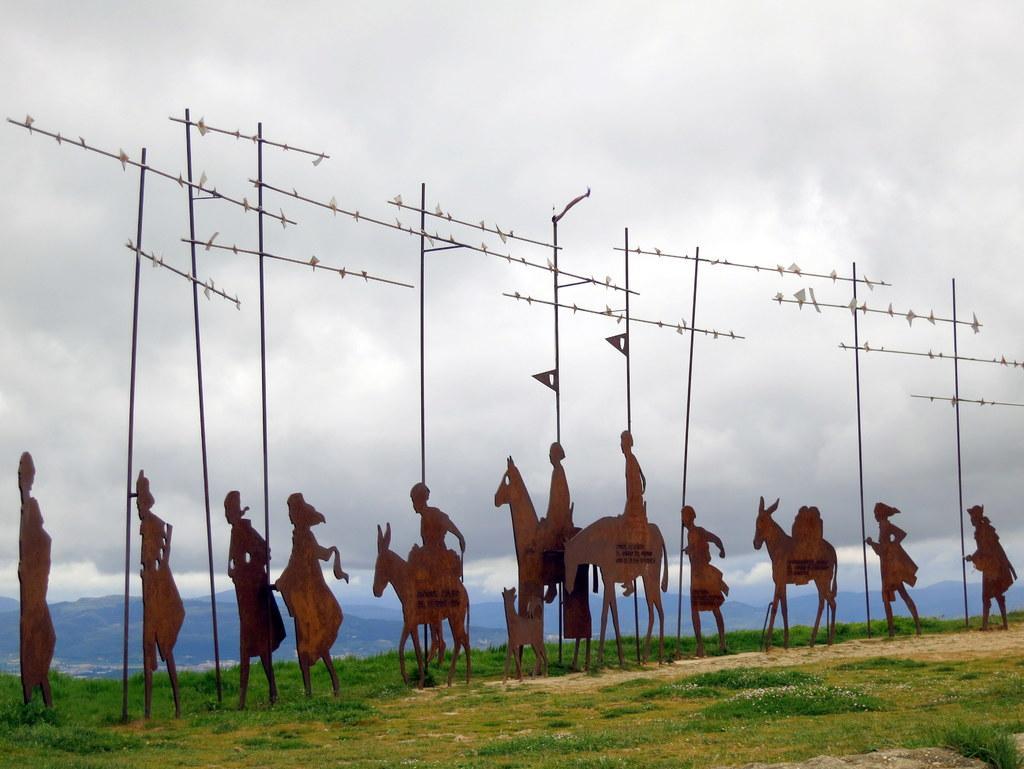Please provide a concise description of this image. In this image there is grass on the ground. On the ground there are poles. Beside the poles there are wooden cutting frames. They are in the designs of humans and animals. In the background there are mountains. At the top there is the sky. 